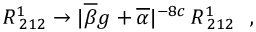Convert formula to latex. <formula><loc_0><loc_0><loc_500><loc_500>R _ { \, 2 1 2 } ^ { 1 } \rightarrow | \overline { \beta } g + \overline { \alpha } | ^ { - 8 c } \, R _ { \, 2 1 2 } ^ { 1 } ,</formula> 